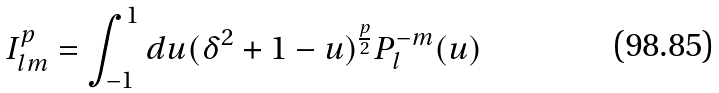Convert formula to latex. <formula><loc_0><loc_0><loc_500><loc_500>I _ { l m } ^ { p } = \int _ { - 1 } ^ { 1 } d u ( \delta ^ { 2 } + 1 - u ) ^ { \frac { p } { 2 } } P _ { l } ^ { - m } ( u )</formula> 